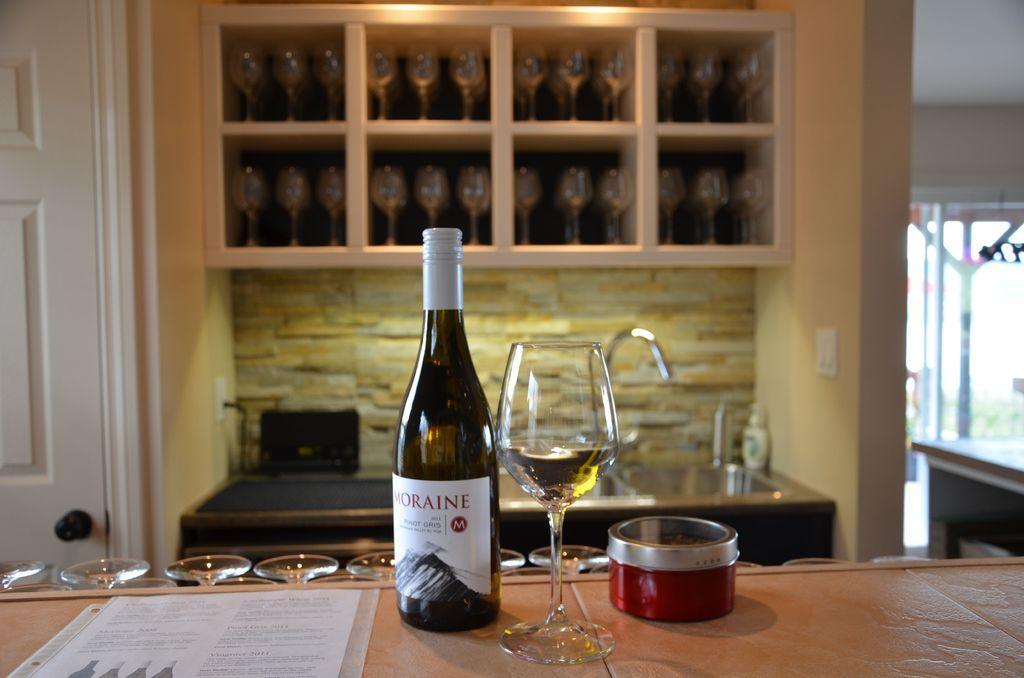Can you describe this image briefly? In this picture we can see a bottle and a glass on the table. Here we can see some glasses in the rack. This is door and there is a wall. 